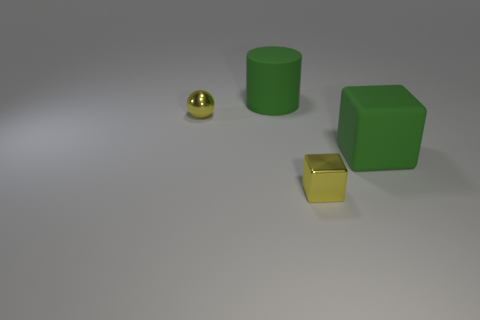Add 3 green objects. How many objects exist? 7 Subtract all cylinders. How many objects are left? 3 Subtract 1 cylinders. How many cylinders are left? 0 Subtract all yellow objects. Subtract all tiny yellow spheres. How many objects are left? 1 Add 1 rubber blocks. How many rubber blocks are left? 2 Add 4 large rubber cylinders. How many large rubber cylinders exist? 5 Subtract 0 brown blocks. How many objects are left? 4 Subtract all gray cubes. Subtract all red balls. How many cubes are left? 2 